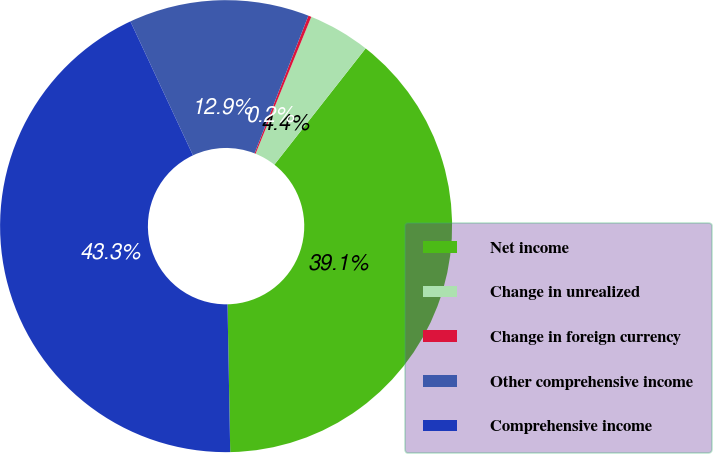Convert chart. <chart><loc_0><loc_0><loc_500><loc_500><pie_chart><fcel>Net income<fcel>Change in unrealized<fcel>Change in foreign currency<fcel>Other comprehensive income<fcel>Comprehensive income<nl><fcel>39.11%<fcel>4.44%<fcel>0.22%<fcel>12.89%<fcel>43.33%<nl></chart> 